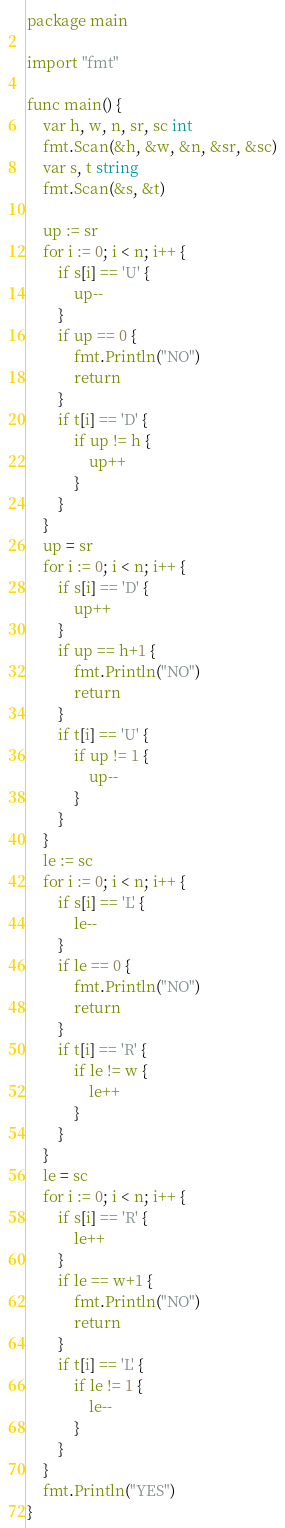Convert code to text. <code><loc_0><loc_0><loc_500><loc_500><_Go_>package main

import "fmt"

func main() {
	var h, w, n, sr, sc int
	fmt.Scan(&h, &w, &n, &sr, &sc)
	var s, t string
	fmt.Scan(&s, &t)

	up := sr
	for i := 0; i < n; i++ {
		if s[i] == 'U' {
			up--
		}
		if up == 0 {
			fmt.Println("NO")
			return
		}
		if t[i] == 'D' {
			if up != h {
				up++
			}
		}
	}
	up = sr
	for i := 0; i < n; i++ {
		if s[i] == 'D' {
			up++
		}
		if up == h+1 {
			fmt.Println("NO")
			return
		}
		if t[i] == 'U' {
			if up != 1 {
				up--
			}
		}
	}
	le := sc
	for i := 0; i < n; i++ {
		if s[i] == 'L' {
			le--
		}
		if le == 0 {
			fmt.Println("NO")
			return
		}
		if t[i] == 'R' {
			if le != w {
				le++
			}
		}
	}
	le = sc
	for i := 0; i < n; i++ {
		if s[i] == 'R' {
			le++
		}
		if le == w+1 {
			fmt.Println("NO")
			return
		}
		if t[i] == 'L' {
			if le != 1 {
				le--
			}
		}
	}
	fmt.Println("YES")
}
</code> 